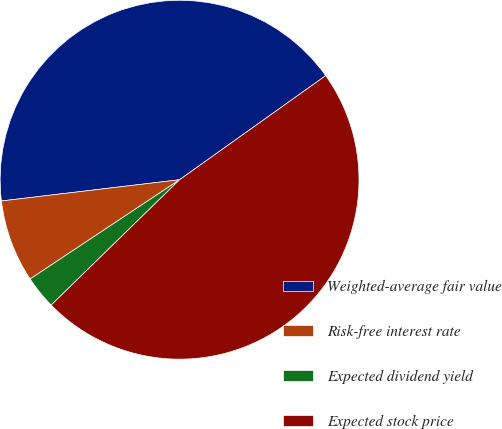Convert chart. <chart><loc_0><loc_0><loc_500><loc_500><pie_chart><fcel>Weighted-average fair value<fcel>Risk-free interest rate<fcel>Expected dividend yield<fcel>Expected stock price<nl><fcel>42.04%<fcel>7.44%<fcel>2.98%<fcel>47.54%<nl></chart> 